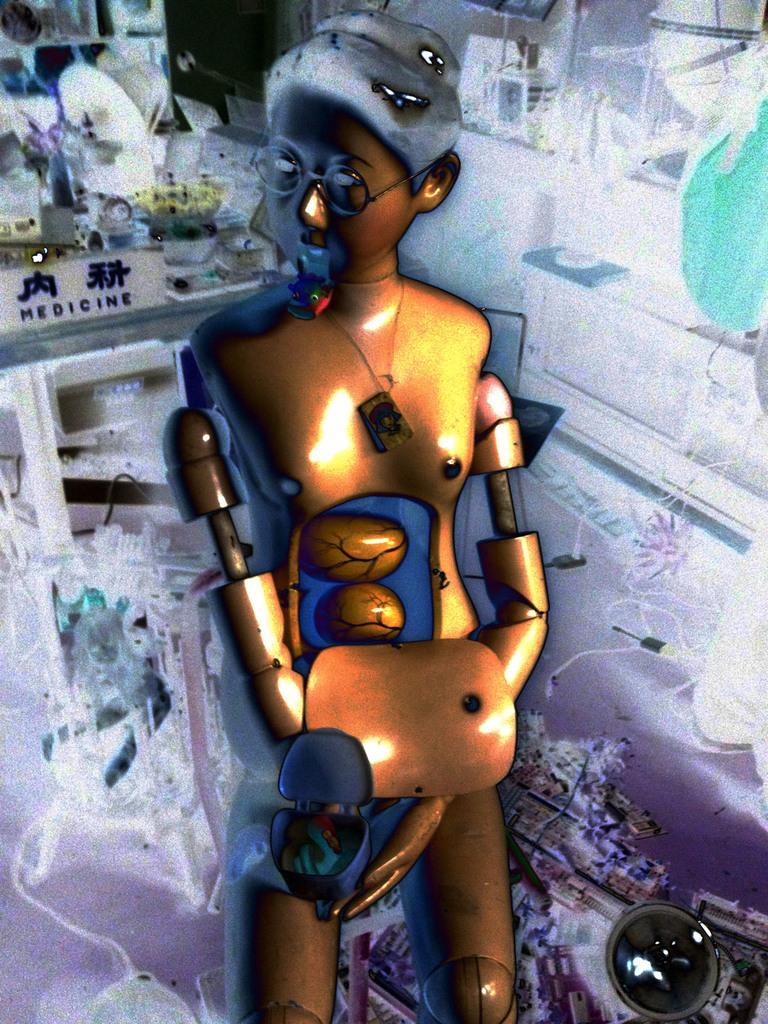Can you describe this image briefly? In this image I can see the toy is yellow and black color. Back I can see few objects and the white color lighting. 